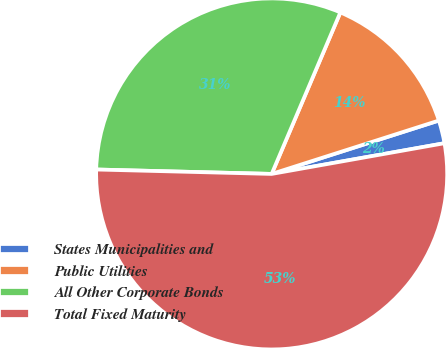<chart> <loc_0><loc_0><loc_500><loc_500><pie_chart><fcel>States Municipalities and<fcel>Public Utilities<fcel>All Other Corporate Bonds<fcel>Total Fixed Maturity<nl><fcel>2.12%<fcel>13.68%<fcel>31.0%<fcel>53.2%<nl></chart> 